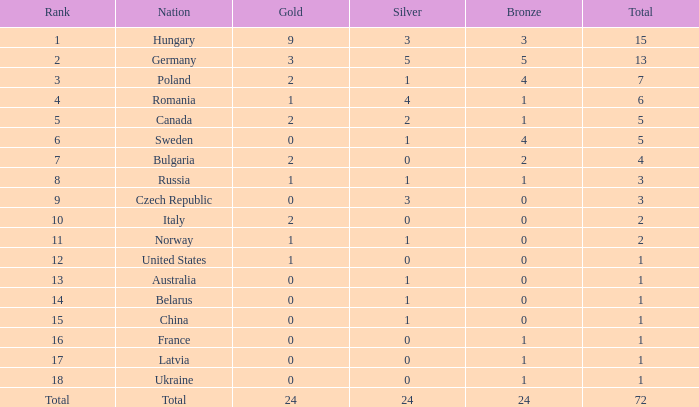What average silver has belarus as the nation, with a total less than 1? None. 